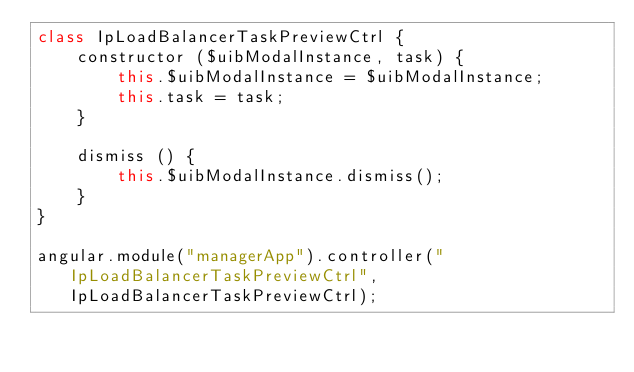<code> <loc_0><loc_0><loc_500><loc_500><_JavaScript_>class IpLoadBalancerTaskPreviewCtrl {
    constructor ($uibModalInstance, task) {
        this.$uibModalInstance = $uibModalInstance;
        this.task = task;
    }

    dismiss () {
        this.$uibModalInstance.dismiss();
    }
}

angular.module("managerApp").controller("IpLoadBalancerTaskPreviewCtrl", IpLoadBalancerTaskPreviewCtrl);
</code> 